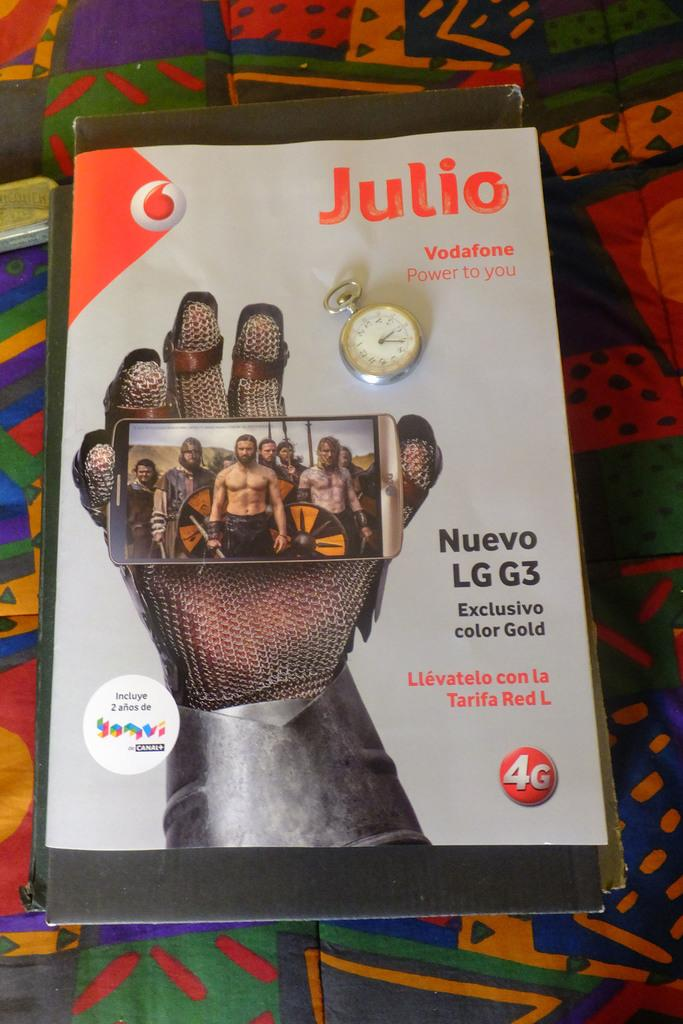<image>
Present a compact description of the photo's key features. Julio magazine has a hand in chain mail on the cover. 